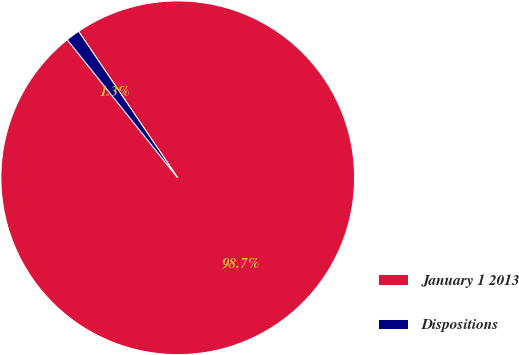Convert chart to OTSL. <chart><loc_0><loc_0><loc_500><loc_500><pie_chart><fcel>January 1 2013<fcel>Dispositions<nl><fcel>98.73%<fcel>1.27%<nl></chart> 